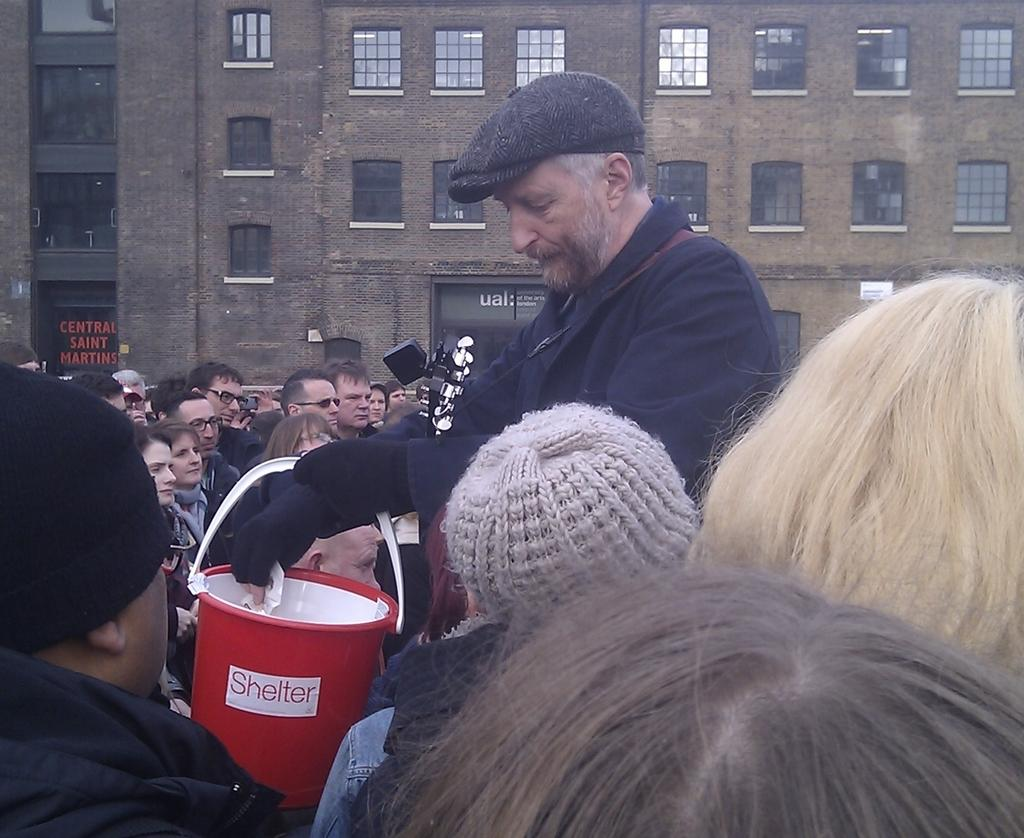How many people are in the image? There is a group of people in the image, but the exact number cannot be determined from the provided facts. What object can be seen in the image that is typically used for holding liquids? There is a bucket in the image. What type of structure is visible in the image? There is a building in the image. What type of pan is being used to join the building in the image? There is no pan or any indication of joining in the image; it only shows a group of people, a bucket, and a building. 